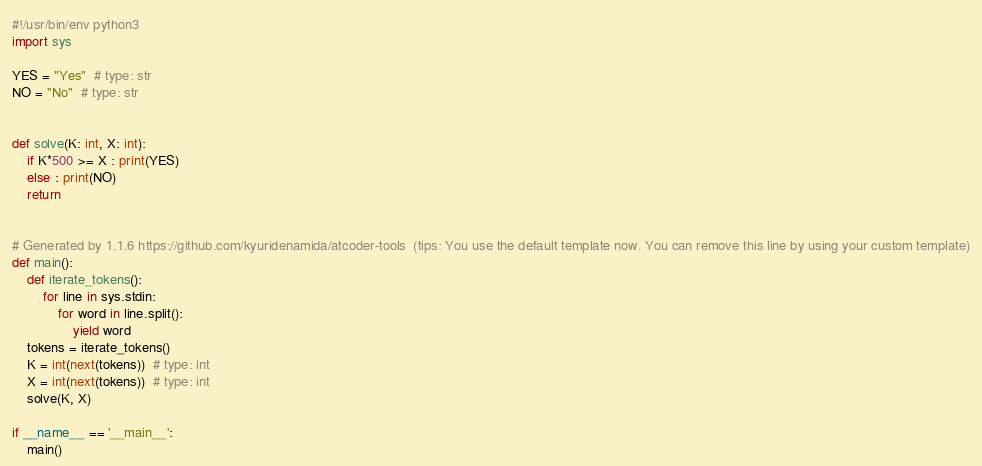<code> <loc_0><loc_0><loc_500><loc_500><_Python_>#!/usr/bin/env python3
import sys

YES = "Yes"  # type: str
NO = "No"  # type: str


def solve(K: int, X: int):
    if K*500 >= X : print(YES)
    else : print(NO)
    return


# Generated by 1.1.6 https://github.com/kyuridenamida/atcoder-tools  (tips: You use the default template now. You can remove this line by using your custom template)
def main():
    def iterate_tokens():
        for line in sys.stdin:
            for word in line.split():
                yield word
    tokens = iterate_tokens()
    K = int(next(tokens))  # type: int
    X = int(next(tokens))  # type: int
    solve(K, X)

if __name__ == '__main__':
    main()
</code> 